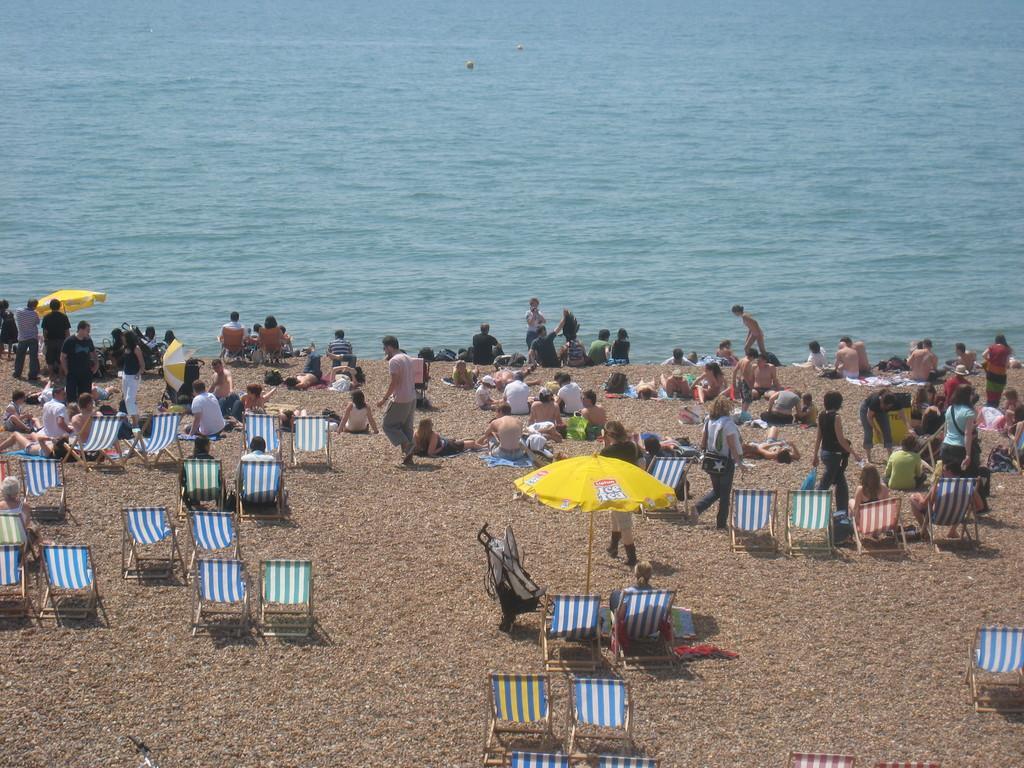Please provide a concise description of this image. In the picture I can see people among them some are sitting and some are walking on the ground. I can also see the water, chairs and some other things. 